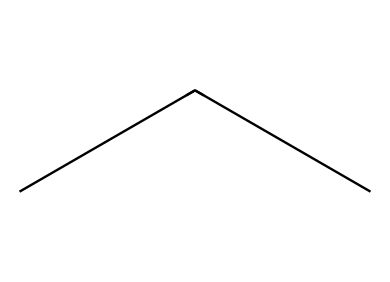What is the molecular formula of propane? The SMILES representation "CCC" indicates three carbon atoms (C) connected in a chain, each with hydrogen atoms filling the remaining valencies. The molecular formula can be deduced as C3H8.
Answer: C3H8 How many carbon atoms are present in propane? By interpreting the SMILES "CCC", we see three consecutive carbon atoms represented, which indicates the number of carbon atoms in the molecule.
Answer: 3 What type of hydrocarbon is propane classified as? Propane, with the structure indicated by "CCC", is a straight-chain alkane, characterized by single C–C bonds and fully saturated with hydrogen.
Answer: alkane What is the total number of hydrogen atoms in propane? The three carbon atoms in propane each form bonds with enough hydrogen atoms to satisfy carbon's tetravalency, resulting in a total of 8 hydrogen atoms.
Answer: 8 Which functional group is absent in propane? The structure represented by "CCC" indicates no double or triple bonds or any functional groups such as hydroxyl or carbonyl, confirming that propane is a saturated hydrocarbon.
Answer: functional group How is propane commonly used in field research? Propane serves as a portable fuel source due to its efficient combustion properties, making it suitable for heating equipment in outdoor research settings.
Answer: heating fuel 